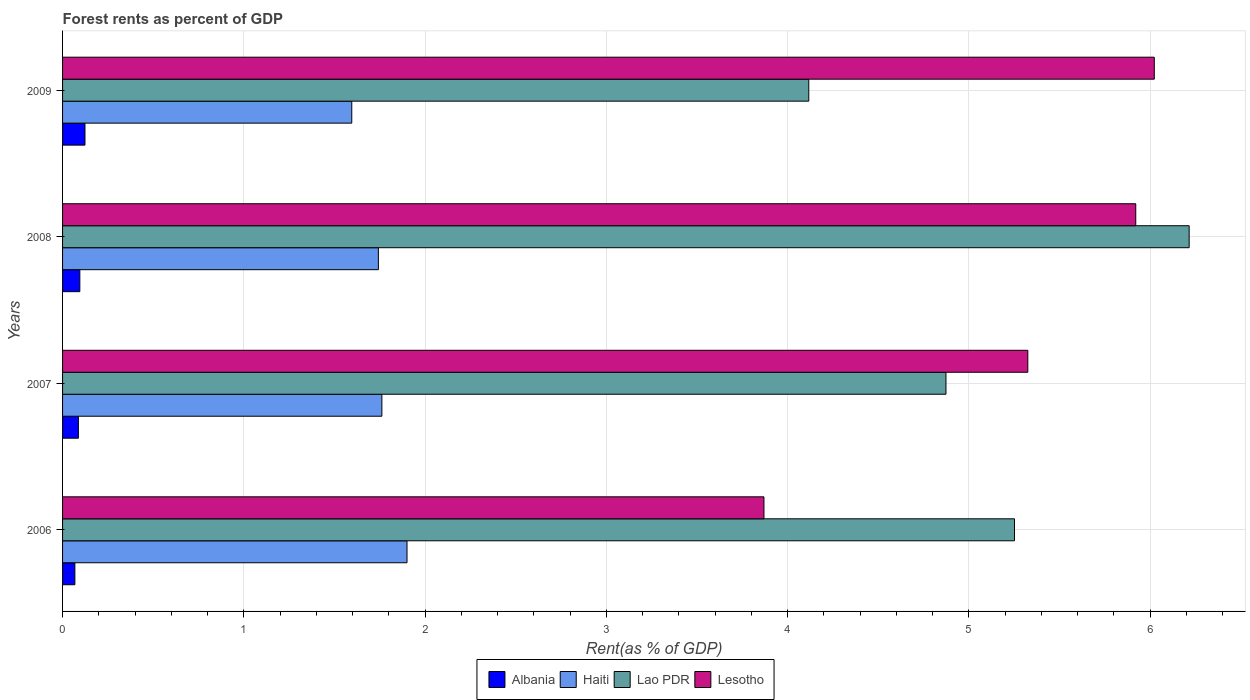How many different coloured bars are there?
Ensure brevity in your answer.  4. How many groups of bars are there?
Make the answer very short. 4. Are the number of bars per tick equal to the number of legend labels?
Keep it short and to the point. Yes. Are the number of bars on each tick of the Y-axis equal?
Make the answer very short. Yes. How many bars are there on the 4th tick from the top?
Provide a succinct answer. 4. How many bars are there on the 1st tick from the bottom?
Offer a terse response. 4. What is the label of the 3rd group of bars from the top?
Offer a very short reply. 2007. What is the forest rent in Lao PDR in 2009?
Keep it short and to the point. 4.12. Across all years, what is the maximum forest rent in Lao PDR?
Offer a terse response. 6.22. Across all years, what is the minimum forest rent in Lesotho?
Provide a short and direct response. 3.87. In which year was the forest rent in Lao PDR minimum?
Your answer should be compact. 2009. What is the total forest rent in Lao PDR in the graph?
Your answer should be compact. 20.46. What is the difference between the forest rent in Haiti in 2006 and that in 2008?
Make the answer very short. 0.16. What is the difference between the forest rent in Lao PDR in 2009 and the forest rent in Lesotho in 2007?
Your answer should be very brief. -1.21. What is the average forest rent in Lesotho per year?
Offer a terse response. 5.29. In the year 2007, what is the difference between the forest rent in Haiti and forest rent in Lao PDR?
Your response must be concise. -3.11. In how many years, is the forest rent in Lesotho greater than 5.4 %?
Your answer should be compact. 2. What is the ratio of the forest rent in Haiti in 2008 to that in 2009?
Offer a very short reply. 1.09. Is the forest rent in Haiti in 2008 less than that in 2009?
Provide a short and direct response. No. Is the difference between the forest rent in Haiti in 2007 and 2009 greater than the difference between the forest rent in Lao PDR in 2007 and 2009?
Provide a succinct answer. No. What is the difference between the highest and the second highest forest rent in Haiti?
Give a very brief answer. 0.14. What is the difference between the highest and the lowest forest rent in Lao PDR?
Offer a terse response. 2.1. In how many years, is the forest rent in Albania greater than the average forest rent in Albania taken over all years?
Provide a succinct answer. 2. Is the sum of the forest rent in Albania in 2008 and 2009 greater than the maximum forest rent in Lesotho across all years?
Keep it short and to the point. No. Is it the case that in every year, the sum of the forest rent in Haiti and forest rent in Lesotho is greater than the sum of forest rent in Albania and forest rent in Lao PDR?
Your answer should be very brief. No. What does the 1st bar from the top in 2008 represents?
Provide a short and direct response. Lesotho. What does the 3rd bar from the bottom in 2009 represents?
Keep it short and to the point. Lao PDR. Does the graph contain any zero values?
Provide a succinct answer. No. Where does the legend appear in the graph?
Your response must be concise. Bottom center. How are the legend labels stacked?
Give a very brief answer. Horizontal. What is the title of the graph?
Offer a terse response. Forest rents as percent of GDP. What is the label or title of the X-axis?
Provide a short and direct response. Rent(as % of GDP). What is the label or title of the Y-axis?
Provide a short and direct response. Years. What is the Rent(as % of GDP) in Albania in 2006?
Provide a succinct answer. 0.07. What is the Rent(as % of GDP) in Haiti in 2006?
Your answer should be compact. 1.9. What is the Rent(as % of GDP) of Lao PDR in 2006?
Your answer should be compact. 5.25. What is the Rent(as % of GDP) in Lesotho in 2006?
Your answer should be compact. 3.87. What is the Rent(as % of GDP) of Albania in 2007?
Your answer should be compact. 0.09. What is the Rent(as % of GDP) of Haiti in 2007?
Your answer should be compact. 1.76. What is the Rent(as % of GDP) of Lao PDR in 2007?
Make the answer very short. 4.87. What is the Rent(as % of GDP) in Lesotho in 2007?
Offer a very short reply. 5.33. What is the Rent(as % of GDP) in Albania in 2008?
Your answer should be very brief. 0.1. What is the Rent(as % of GDP) of Haiti in 2008?
Provide a short and direct response. 1.74. What is the Rent(as % of GDP) of Lao PDR in 2008?
Make the answer very short. 6.22. What is the Rent(as % of GDP) in Lesotho in 2008?
Offer a terse response. 5.92. What is the Rent(as % of GDP) in Albania in 2009?
Your answer should be very brief. 0.12. What is the Rent(as % of GDP) in Haiti in 2009?
Provide a succinct answer. 1.6. What is the Rent(as % of GDP) of Lao PDR in 2009?
Your answer should be compact. 4.12. What is the Rent(as % of GDP) in Lesotho in 2009?
Give a very brief answer. 6.02. Across all years, what is the maximum Rent(as % of GDP) in Albania?
Keep it short and to the point. 0.12. Across all years, what is the maximum Rent(as % of GDP) in Haiti?
Keep it short and to the point. 1.9. Across all years, what is the maximum Rent(as % of GDP) in Lao PDR?
Offer a terse response. 6.22. Across all years, what is the maximum Rent(as % of GDP) of Lesotho?
Keep it short and to the point. 6.02. Across all years, what is the minimum Rent(as % of GDP) of Albania?
Keep it short and to the point. 0.07. Across all years, what is the minimum Rent(as % of GDP) in Haiti?
Your response must be concise. 1.6. Across all years, what is the minimum Rent(as % of GDP) of Lao PDR?
Offer a very short reply. 4.12. Across all years, what is the minimum Rent(as % of GDP) of Lesotho?
Give a very brief answer. 3.87. What is the total Rent(as % of GDP) in Albania in the graph?
Give a very brief answer. 0.37. What is the total Rent(as % of GDP) of Haiti in the graph?
Provide a succinct answer. 7. What is the total Rent(as % of GDP) in Lao PDR in the graph?
Your answer should be very brief. 20.46. What is the total Rent(as % of GDP) of Lesotho in the graph?
Give a very brief answer. 21.14. What is the difference between the Rent(as % of GDP) in Albania in 2006 and that in 2007?
Provide a short and direct response. -0.02. What is the difference between the Rent(as % of GDP) of Haiti in 2006 and that in 2007?
Make the answer very short. 0.14. What is the difference between the Rent(as % of GDP) in Lao PDR in 2006 and that in 2007?
Offer a terse response. 0.38. What is the difference between the Rent(as % of GDP) of Lesotho in 2006 and that in 2007?
Keep it short and to the point. -1.46. What is the difference between the Rent(as % of GDP) of Albania in 2006 and that in 2008?
Offer a very short reply. -0.03. What is the difference between the Rent(as % of GDP) in Haiti in 2006 and that in 2008?
Keep it short and to the point. 0.16. What is the difference between the Rent(as % of GDP) of Lao PDR in 2006 and that in 2008?
Offer a terse response. -0.96. What is the difference between the Rent(as % of GDP) of Lesotho in 2006 and that in 2008?
Offer a terse response. -2.05. What is the difference between the Rent(as % of GDP) of Albania in 2006 and that in 2009?
Ensure brevity in your answer.  -0.06. What is the difference between the Rent(as % of GDP) of Haiti in 2006 and that in 2009?
Keep it short and to the point. 0.3. What is the difference between the Rent(as % of GDP) of Lao PDR in 2006 and that in 2009?
Give a very brief answer. 1.13. What is the difference between the Rent(as % of GDP) in Lesotho in 2006 and that in 2009?
Your answer should be compact. -2.15. What is the difference between the Rent(as % of GDP) of Albania in 2007 and that in 2008?
Keep it short and to the point. -0.01. What is the difference between the Rent(as % of GDP) in Haiti in 2007 and that in 2008?
Provide a succinct answer. 0.02. What is the difference between the Rent(as % of GDP) in Lao PDR in 2007 and that in 2008?
Ensure brevity in your answer.  -1.34. What is the difference between the Rent(as % of GDP) of Lesotho in 2007 and that in 2008?
Give a very brief answer. -0.6. What is the difference between the Rent(as % of GDP) in Albania in 2007 and that in 2009?
Your response must be concise. -0.04. What is the difference between the Rent(as % of GDP) in Haiti in 2007 and that in 2009?
Provide a succinct answer. 0.17. What is the difference between the Rent(as % of GDP) in Lao PDR in 2007 and that in 2009?
Your answer should be compact. 0.76. What is the difference between the Rent(as % of GDP) of Lesotho in 2007 and that in 2009?
Give a very brief answer. -0.7. What is the difference between the Rent(as % of GDP) of Albania in 2008 and that in 2009?
Offer a very short reply. -0.03. What is the difference between the Rent(as % of GDP) of Haiti in 2008 and that in 2009?
Give a very brief answer. 0.15. What is the difference between the Rent(as % of GDP) in Lao PDR in 2008 and that in 2009?
Ensure brevity in your answer.  2.1. What is the difference between the Rent(as % of GDP) of Lesotho in 2008 and that in 2009?
Your answer should be very brief. -0.1. What is the difference between the Rent(as % of GDP) in Albania in 2006 and the Rent(as % of GDP) in Haiti in 2007?
Your response must be concise. -1.69. What is the difference between the Rent(as % of GDP) of Albania in 2006 and the Rent(as % of GDP) of Lao PDR in 2007?
Ensure brevity in your answer.  -4.81. What is the difference between the Rent(as % of GDP) of Albania in 2006 and the Rent(as % of GDP) of Lesotho in 2007?
Provide a short and direct response. -5.26. What is the difference between the Rent(as % of GDP) of Haiti in 2006 and the Rent(as % of GDP) of Lao PDR in 2007?
Your response must be concise. -2.97. What is the difference between the Rent(as % of GDP) in Haiti in 2006 and the Rent(as % of GDP) in Lesotho in 2007?
Offer a very short reply. -3.43. What is the difference between the Rent(as % of GDP) of Lao PDR in 2006 and the Rent(as % of GDP) of Lesotho in 2007?
Your answer should be compact. -0.07. What is the difference between the Rent(as % of GDP) in Albania in 2006 and the Rent(as % of GDP) in Haiti in 2008?
Offer a terse response. -1.67. What is the difference between the Rent(as % of GDP) in Albania in 2006 and the Rent(as % of GDP) in Lao PDR in 2008?
Provide a succinct answer. -6.15. What is the difference between the Rent(as % of GDP) of Albania in 2006 and the Rent(as % of GDP) of Lesotho in 2008?
Give a very brief answer. -5.85. What is the difference between the Rent(as % of GDP) in Haiti in 2006 and the Rent(as % of GDP) in Lao PDR in 2008?
Give a very brief answer. -4.32. What is the difference between the Rent(as % of GDP) in Haiti in 2006 and the Rent(as % of GDP) in Lesotho in 2008?
Provide a short and direct response. -4.02. What is the difference between the Rent(as % of GDP) in Lao PDR in 2006 and the Rent(as % of GDP) in Lesotho in 2008?
Offer a very short reply. -0.67. What is the difference between the Rent(as % of GDP) of Albania in 2006 and the Rent(as % of GDP) of Haiti in 2009?
Your response must be concise. -1.53. What is the difference between the Rent(as % of GDP) in Albania in 2006 and the Rent(as % of GDP) in Lao PDR in 2009?
Ensure brevity in your answer.  -4.05. What is the difference between the Rent(as % of GDP) in Albania in 2006 and the Rent(as % of GDP) in Lesotho in 2009?
Ensure brevity in your answer.  -5.96. What is the difference between the Rent(as % of GDP) of Haiti in 2006 and the Rent(as % of GDP) of Lao PDR in 2009?
Offer a terse response. -2.22. What is the difference between the Rent(as % of GDP) of Haiti in 2006 and the Rent(as % of GDP) of Lesotho in 2009?
Your answer should be very brief. -4.12. What is the difference between the Rent(as % of GDP) in Lao PDR in 2006 and the Rent(as % of GDP) in Lesotho in 2009?
Give a very brief answer. -0.77. What is the difference between the Rent(as % of GDP) in Albania in 2007 and the Rent(as % of GDP) in Haiti in 2008?
Give a very brief answer. -1.66. What is the difference between the Rent(as % of GDP) of Albania in 2007 and the Rent(as % of GDP) of Lao PDR in 2008?
Offer a very short reply. -6.13. What is the difference between the Rent(as % of GDP) of Albania in 2007 and the Rent(as % of GDP) of Lesotho in 2008?
Offer a terse response. -5.83. What is the difference between the Rent(as % of GDP) in Haiti in 2007 and the Rent(as % of GDP) in Lao PDR in 2008?
Ensure brevity in your answer.  -4.45. What is the difference between the Rent(as % of GDP) of Haiti in 2007 and the Rent(as % of GDP) of Lesotho in 2008?
Offer a very short reply. -4.16. What is the difference between the Rent(as % of GDP) of Lao PDR in 2007 and the Rent(as % of GDP) of Lesotho in 2008?
Offer a very short reply. -1.05. What is the difference between the Rent(as % of GDP) in Albania in 2007 and the Rent(as % of GDP) in Haiti in 2009?
Ensure brevity in your answer.  -1.51. What is the difference between the Rent(as % of GDP) of Albania in 2007 and the Rent(as % of GDP) of Lao PDR in 2009?
Give a very brief answer. -4.03. What is the difference between the Rent(as % of GDP) of Albania in 2007 and the Rent(as % of GDP) of Lesotho in 2009?
Provide a short and direct response. -5.94. What is the difference between the Rent(as % of GDP) in Haiti in 2007 and the Rent(as % of GDP) in Lao PDR in 2009?
Offer a very short reply. -2.36. What is the difference between the Rent(as % of GDP) in Haiti in 2007 and the Rent(as % of GDP) in Lesotho in 2009?
Give a very brief answer. -4.26. What is the difference between the Rent(as % of GDP) of Lao PDR in 2007 and the Rent(as % of GDP) of Lesotho in 2009?
Make the answer very short. -1.15. What is the difference between the Rent(as % of GDP) of Albania in 2008 and the Rent(as % of GDP) of Haiti in 2009?
Keep it short and to the point. -1.5. What is the difference between the Rent(as % of GDP) in Albania in 2008 and the Rent(as % of GDP) in Lao PDR in 2009?
Ensure brevity in your answer.  -4.02. What is the difference between the Rent(as % of GDP) in Albania in 2008 and the Rent(as % of GDP) in Lesotho in 2009?
Give a very brief answer. -5.93. What is the difference between the Rent(as % of GDP) of Haiti in 2008 and the Rent(as % of GDP) of Lao PDR in 2009?
Your answer should be very brief. -2.37. What is the difference between the Rent(as % of GDP) of Haiti in 2008 and the Rent(as % of GDP) of Lesotho in 2009?
Your response must be concise. -4.28. What is the difference between the Rent(as % of GDP) in Lao PDR in 2008 and the Rent(as % of GDP) in Lesotho in 2009?
Your answer should be compact. 0.19. What is the average Rent(as % of GDP) of Albania per year?
Keep it short and to the point. 0.09. What is the average Rent(as % of GDP) of Haiti per year?
Provide a succinct answer. 1.75. What is the average Rent(as % of GDP) of Lao PDR per year?
Offer a terse response. 5.11. What is the average Rent(as % of GDP) in Lesotho per year?
Provide a short and direct response. 5.29. In the year 2006, what is the difference between the Rent(as % of GDP) in Albania and Rent(as % of GDP) in Haiti?
Your answer should be very brief. -1.83. In the year 2006, what is the difference between the Rent(as % of GDP) in Albania and Rent(as % of GDP) in Lao PDR?
Make the answer very short. -5.18. In the year 2006, what is the difference between the Rent(as % of GDP) of Albania and Rent(as % of GDP) of Lesotho?
Your answer should be very brief. -3.8. In the year 2006, what is the difference between the Rent(as % of GDP) of Haiti and Rent(as % of GDP) of Lao PDR?
Your answer should be compact. -3.35. In the year 2006, what is the difference between the Rent(as % of GDP) in Haiti and Rent(as % of GDP) in Lesotho?
Ensure brevity in your answer.  -1.97. In the year 2006, what is the difference between the Rent(as % of GDP) of Lao PDR and Rent(as % of GDP) of Lesotho?
Give a very brief answer. 1.38. In the year 2007, what is the difference between the Rent(as % of GDP) of Albania and Rent(as % of GDP) of Haiti?
Ensure brevity in your answer.  -1.67. In the year 2007, what is the difference between the Rent(as % of GDP) in Albania and Rent(as % of GDP) in Lao PDR?
Keep it short and to the point. -4.79. In the year 2007, what is the difference between the Rent(as % of GDP) in Albania and Rent(as % of GDP) in Lesotho?
Keep it short and to the point. -5.24. In the year 2007, what is the difference between the Rent(as % of GDP) in Haiti and Rent(as % of GDP) in Lao PDR?
Provide a succinct answer. -3.11. In the year 2007, what is the difference between the Rent(as % of GDP) of Haiti and Rent(as % of GDP) of Lesotho?
Offer a terse response. -3.56. In the year 2007, what is the difference between the Rent(as % of GDP) of Lao PDR and Rent(as % of GDP) of Lesotho?
Your answer should be compact. -0.45. In the year 2008, what is the difference between the Rent(as % of GDP) in Albania and Rent(as % of GDP) in Haiti?
Offer a terse response. -1.65. In the year 2008, what is the difference between the Rent(as % of GDP) of Albania and Rent(as % of GDP) of Lao PDR?
Offer a very short reply. -6.12. In the year 2008, what is the difference between the Rent(as % of GDP) of Albania and Rent(as % of GDP) of Lesotho?
Provide a short and direct response. -5.83. In the year 2008, what is the difference between the Rent(as % of GDP) in Haiti and Rent(as % of GDP) in Lao PDR?
Your response must be concise. -4.47. In the year 2008, what is the difference between the Rent(as % of GDP) in Haiti and Rent(as % of GDP) in Lesotho?
Make the answer very short. -4.18. In the year 2008, what is the difference between the Rent(as % of GDP) of Lao PDR and Rent(as % of GDP) of Lesotho?
Your response must be concise. 0.29. In the year 2009, what is the difference between the Rent(as % of GDP) in Albania and Rent(as % of GDP) in Haiti?
Your answer should be very brief. -1.47. In the year 2009, what is the difference between the Rent(as % of GDP) in Albania and Rent(as % of GDP) in Lao PDR?
Your answer should be compact. -3.99. In the year 2009, what is the difference between the Rent(as % of GDP) of Albania and Rent(as % of GDP) of Lesotho?
Ensure brevity in your answer.  -5.9. In the year 2009, what is the difference between the Rent(as % of GDP) of Haiti and Rent(as % of GDP) of Lao PDR?
Your answer should be very brief. -2.52. In the year 2009, what is the difference between the Rent(as % of GDP) of Haiti and Rent(as % of GDP) of Lesotho?
Make the answer very short. -4.43. In the year 2009, what is the difference between the Rent(as % of GDP) of Lao PDR and Rent(as % of GDP) of Lesotho?
Ensure brevity in your answer.  -1.91. What is the ratio of the Rent(as % of GDP) in Haiti in 2006 to that in 2007?
Keep it short and to the point. 1.08. What is the ratio of the Rent(as % of GDP) in Lao PDR in 2006 to that in 2007?
Provide a short and direct response. 1.08. What is the ratio of the Rent(as % of GDP) in Lesotho in 2006 to that in 2007?
Offer a terse response. 0.73. What is the ratio of the Rent(as % of GDP) in Albania in 2006 to that in 2008?
Ensure brevity in your answer.  0.71. What is the ratio of the Rent(as % of GDP) of Haiti in 2006 to that in 2008?
Keep it short and to the point. 1.09. What is the ratio of the Rent(as % of GDP) in Lao PDR in 2006 to that in 2008?
Your answer should be compact. 0.84. What is the ratio of the Rent(as % of GDP) of Lesotho in 2006 to that in 2008?
Provide a succinct answer. 0.65. What is the ratio of the Rent(as % of GDP) of Albania in 2006 to that in 2009?
Provide a short and direct response. 0.55. What is the ratio of the Rent(as % of GDP) of Haiti in 2006 to that in 2009?
Keep it short and to the point. 1.19. What is the ratio of the Rent(as % of GDP) in Lao PDR in 2006 to that in 2009?
Offer a very short reply. 1.28. What is the ratio of the Rent(as % of GDP) of Lesotho in 2006 to that in 2009?
Offer a very short reply. 0.64. What is the ratio of the Rent(as % of GDP) in Albania in 2007 to that in 2008?
Make the answer very short. 0.92. What is the ratio of the Rent(as % of GDP) of Haiti in 2007 to that in 2008?
Your answer should be very brief. 1.01. What is the ratio of the Rent(as % of GDP) in Lao PDR in 2007 to that in 2008?
Ensure brevity in your answer.  0.78. What is the ratio of the Rent(as % of GDP) in Lesotho in 2007 to that in 2008?
Ensure brevity in your answer.  0.9. What is the ratio of the Rent(as % of GDP) of Albania in 2007 to that in 2009?
Your answer should be compact. 0.71. What is the ratio of the Rent(as % of GDP) in Haiti in 2007 to that in 2009?
Your response must be concise. 1.1. What is the ratio of the Rent(as % of GDP) in Lao PDR in 2007 to that in 2009?
Your answer should be very brief. 1.18. What is the ratio of the Rent(as % of GDP) of Lesotho in 2007 to that in 2009?
Give a very brief answer. 0.88. What is the ratio of the Rent(as % of GDP) in Albania in 2008 to that in 2009?
Offer a terse response. 0.77. What is the ratio of the Rent(as % of GDP) in Haiti in 2008 to that in 2009?
Make the answer very short. 1.09. What is the ratio of the Rent(as % of GDP) of Lao PDR in 2008 to that in 2009?
Make the answer very short. 1.51. What is the ratio of the Rent(as % of GDP) in Lesotho in 2008 to that in 2009?
Provide a short and direct response. 0.98. What is the difference between the highest and the second highest Rent(as % of GDP) of Albania?
Make the answer very short. 0.03. What is the difference between the highest and the second highest Rent(as % of GDP) in Haiti?
Offer a terse response. 0.14. What is the difference between the highest and the second highest Rent(as % of GDP) of Lao PDR?
Provide a succinct answer. 0.96. What is the difference between the highest and the second highest Rent(as % of GDP) in Lesotho?
Keep it short and to the point. 0.1. What is the difference between the highest and the lowest Rent(as % of GDP) in Albania?
Offer a very short reply. 0.06. What is the difference between the highest and the lowest Rent(as % of GDP) of Haiti?
Offer a very short reply. 0.3. What is the difference between the highest and the lowest Rent(as % of GDP) in Lao PDR?
Make the answer very short. 2.1. What is the difference between the highest and the lowest Rent(as % of GDP) of Lesotho?
Your answer should be very brief. 2.15. 